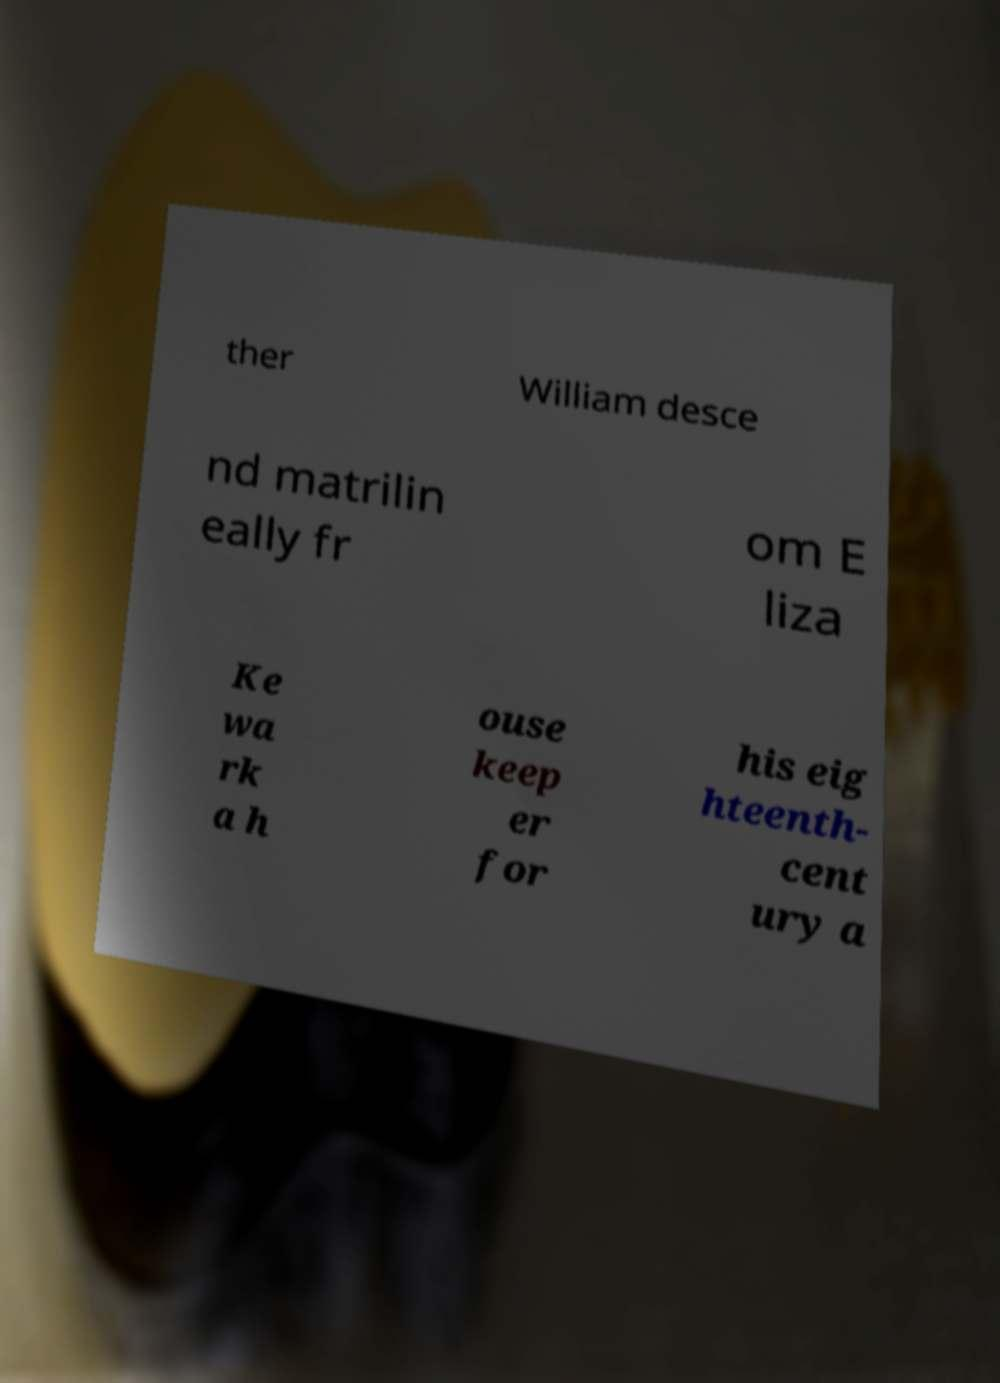Can you read and provide the text displayed in the image?This photo seems to have some interesting text. Can you extract and type it out for me? ther William desce nd matrilin eally fr om E liza Ke wa rk a h ouse keep er for his eig hteenth- cent ury a 